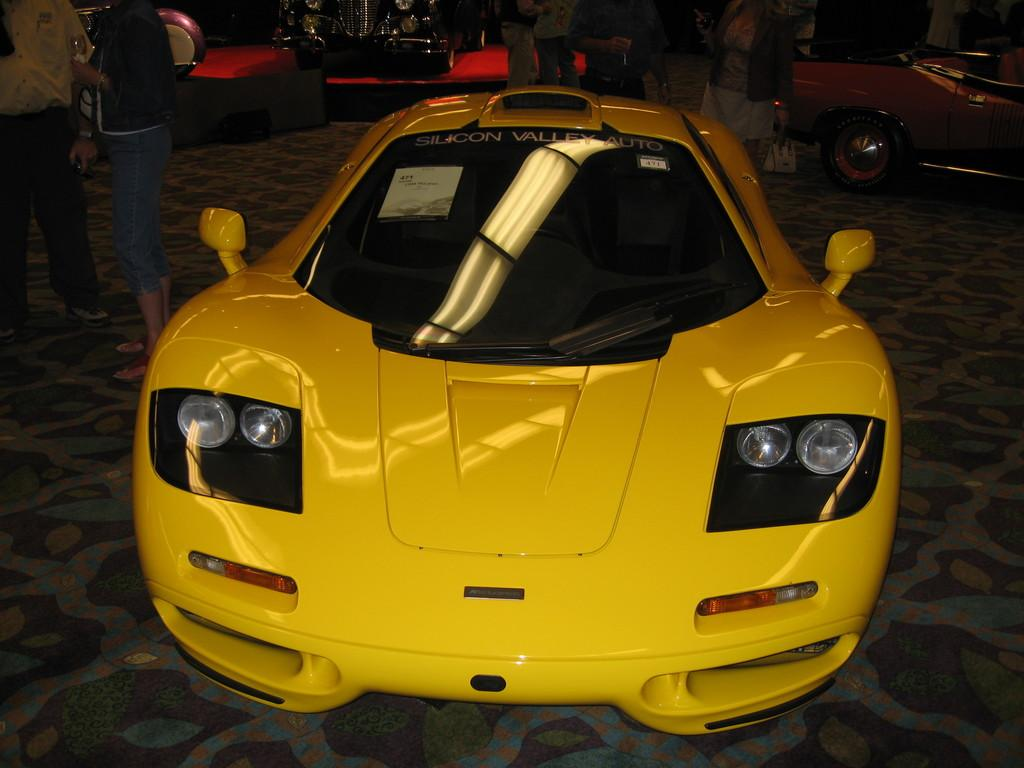What types of vehicles can be seen in the image? There are vehicles in the image, but the specific types are not mentioned. What are the people holding in the image? There are people holding objects in the image, but the nature of these objects is not specified. Can you describe the background of the image? There are other objects visible in the background of the image, but their details are not provided. Are there any snails visible in the image? There is no mention of snails in the provided facts, so it cannot be determined if any are present in the image. 